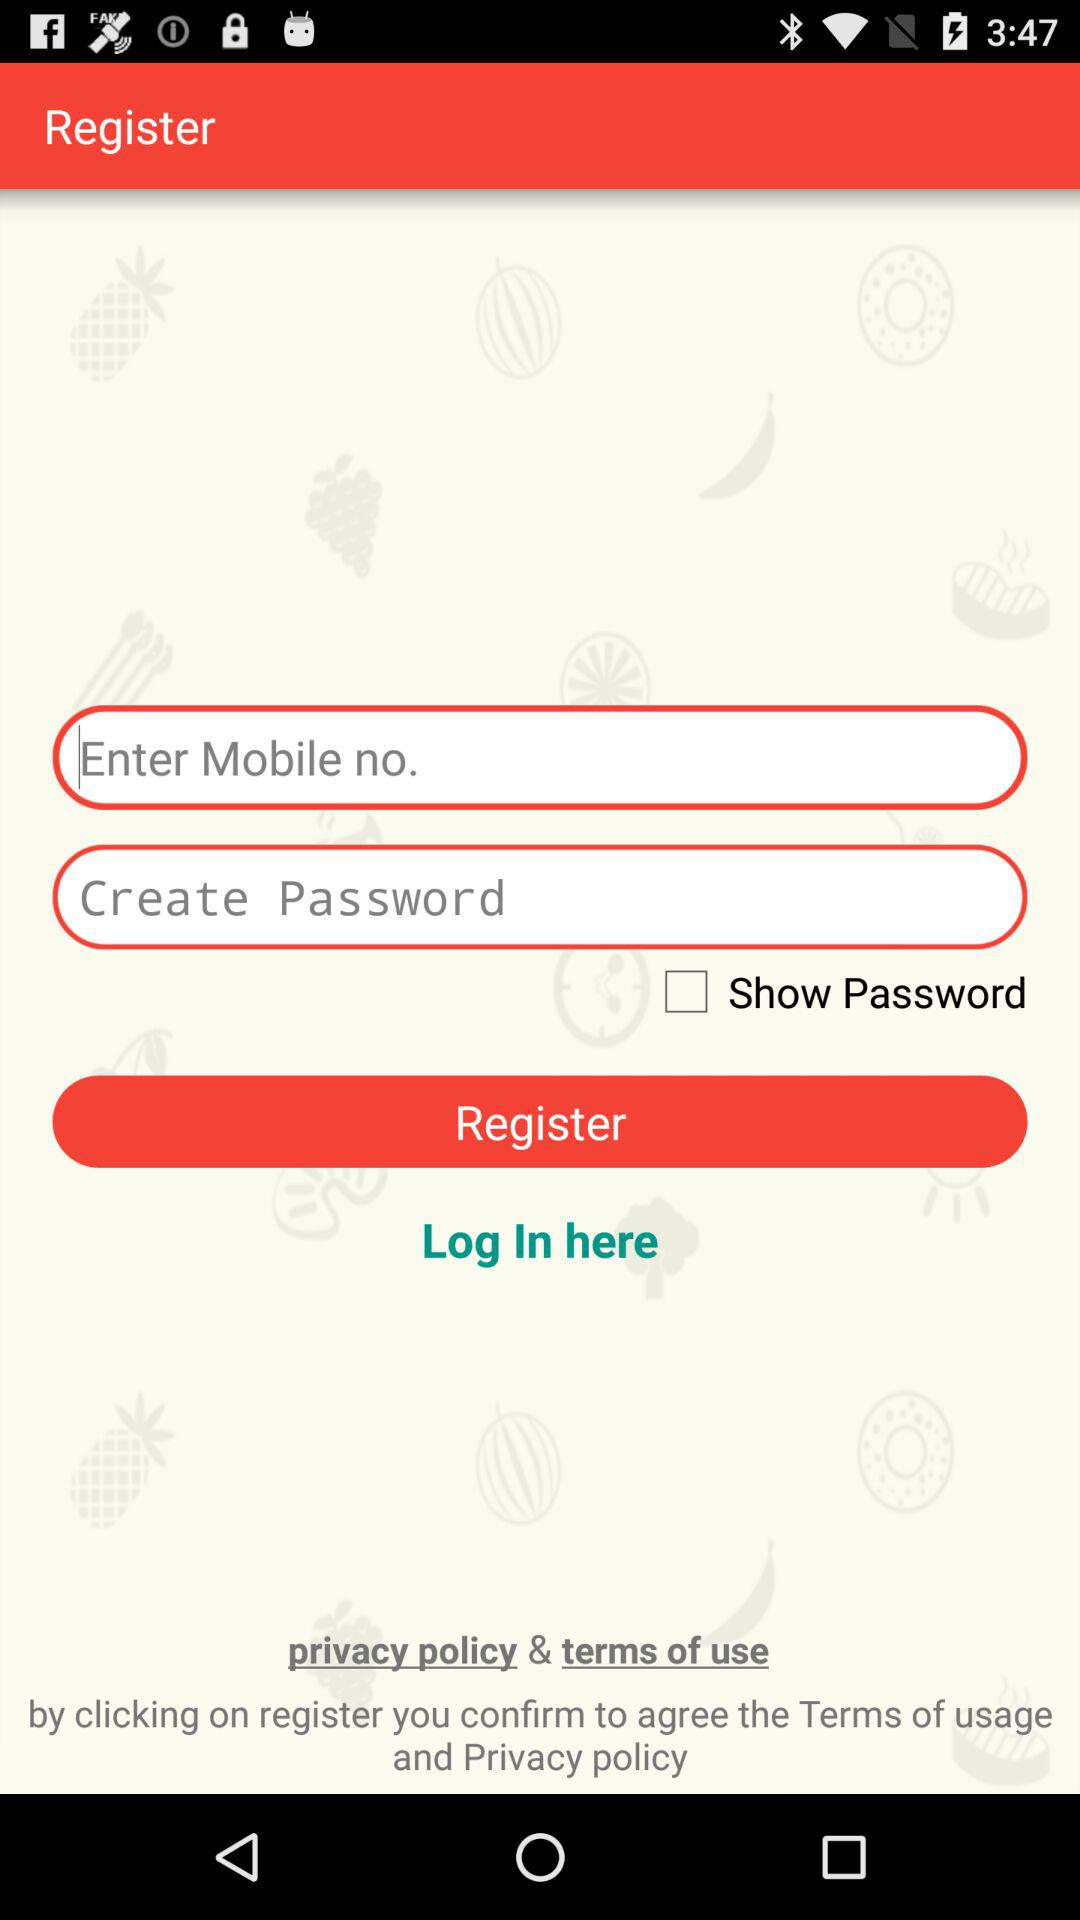What is the status of the "Show Password"? The status is "off". 